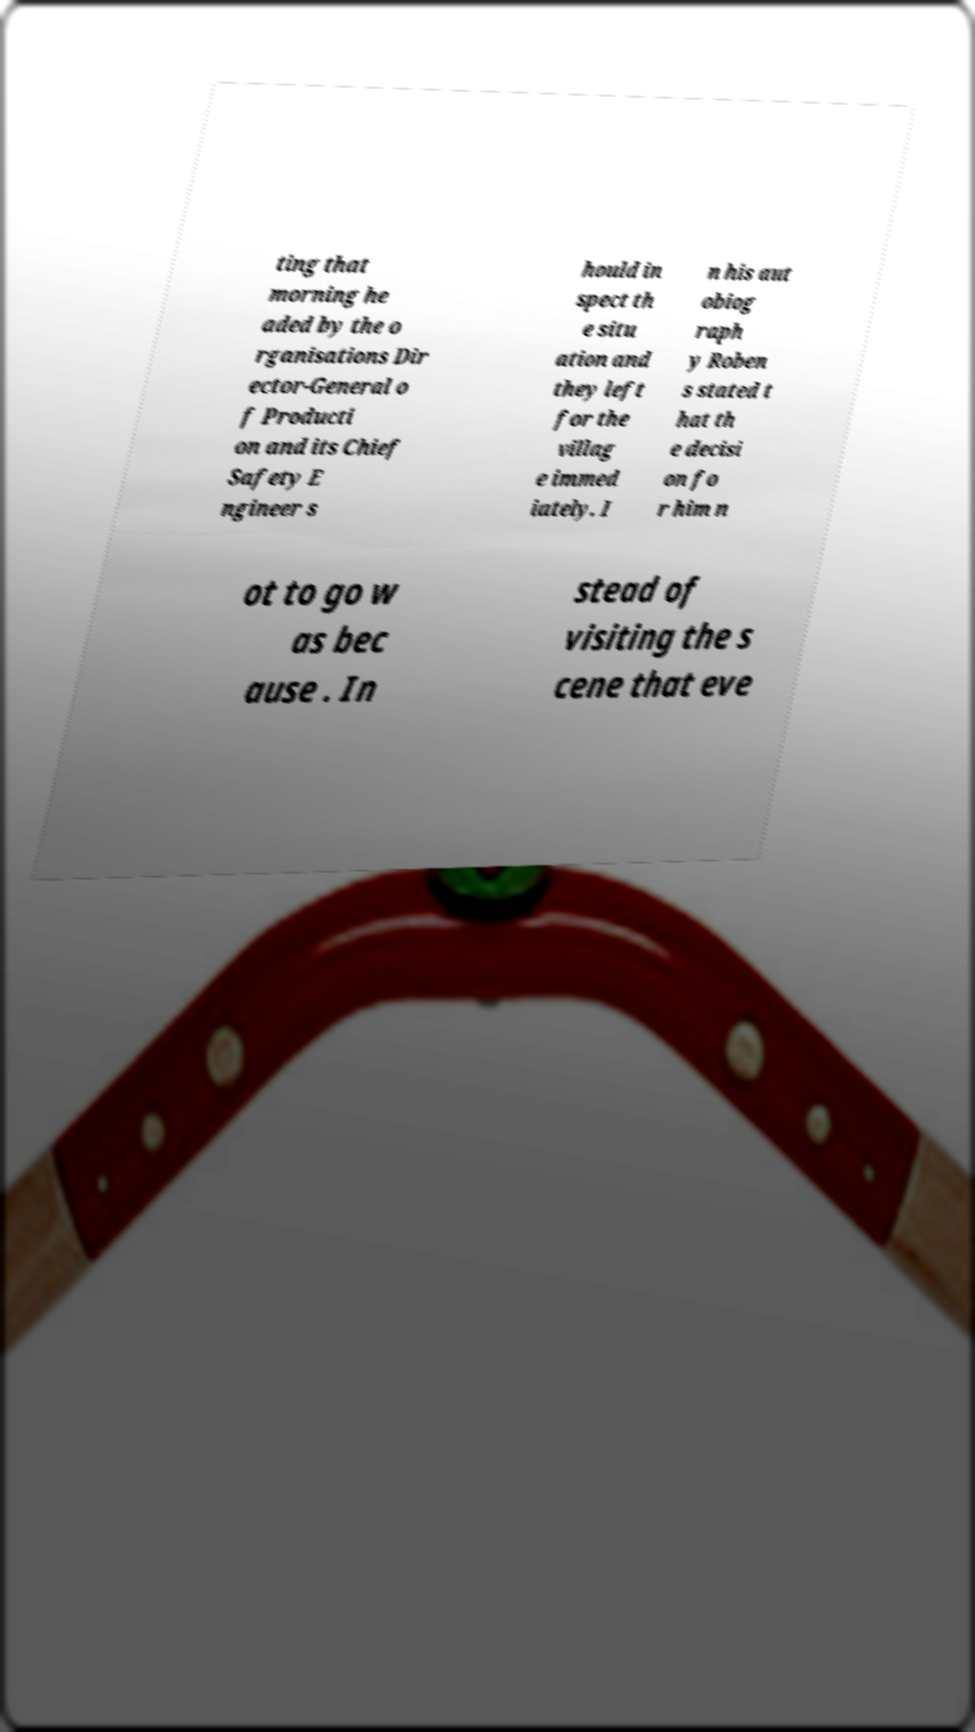Could you assist in decoding the text presented in this image and type it out clearly? ting that morning he aded by the o rganisations Dir ector-General o f Producti on and its Chief Safety E ngineer s hould in spect th e situ ation and they left for the villag e immed iately. I n his aut obiog raph y Roben s stated t hat th e decisi on fo r him n ot to go w as bec ause . In stead of visiting the s cene that eve 